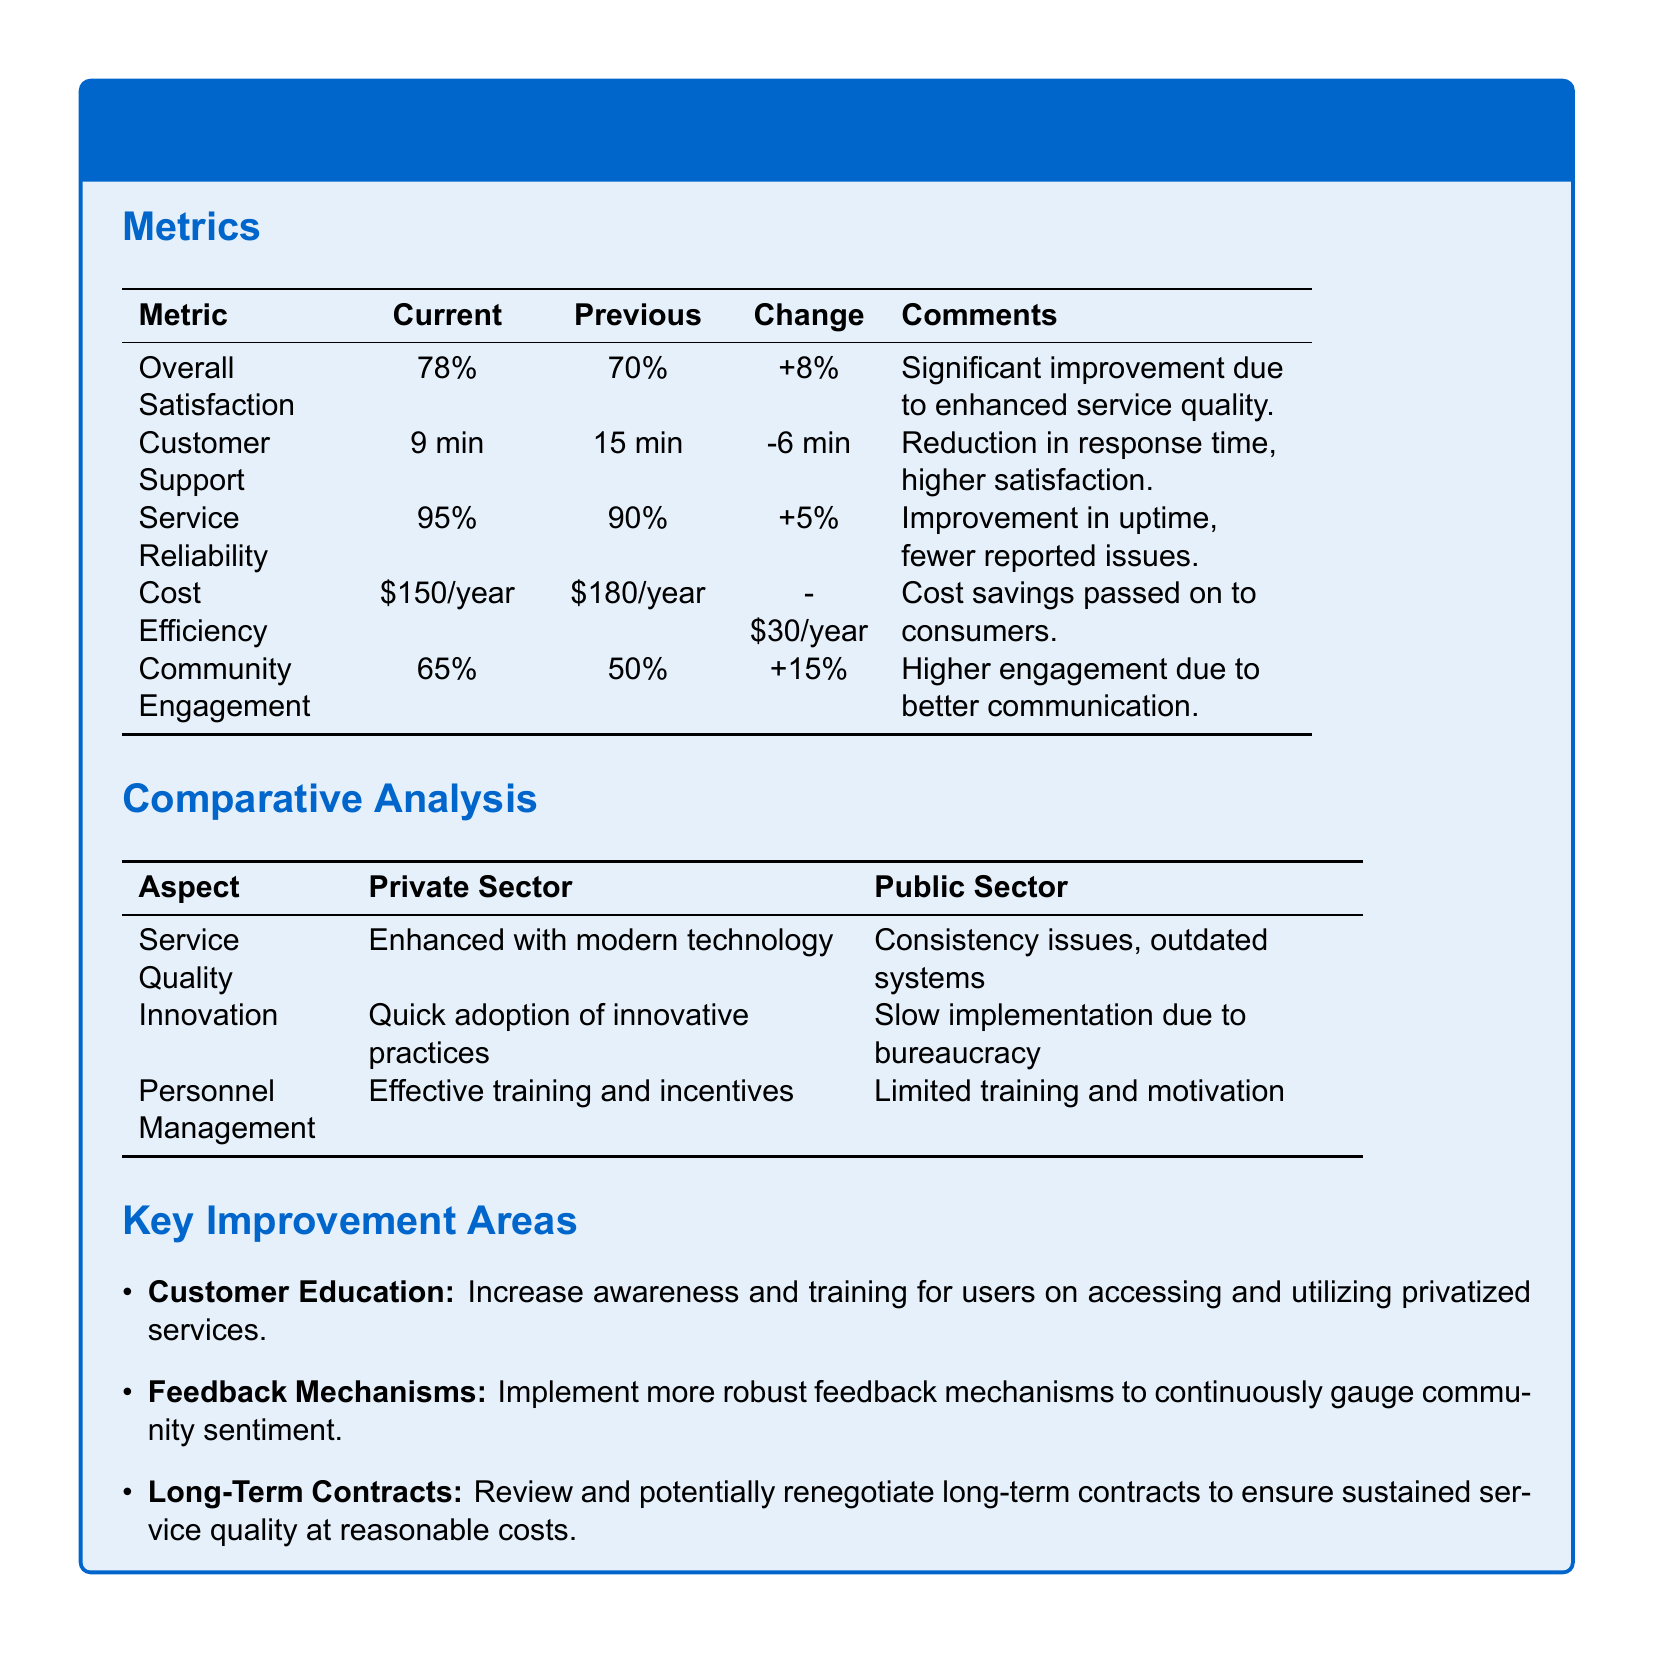What is the overall satisfaction percentage? The overall satisfaction percentage is stated as the current value in the metrics section, which shows a clear figure for current and previous.
Answer: 78% What was the customer support response time previously? The previous customer support response time is clearly listed in the metrics section for ease of comparison.
Answer: 15 min What is the change in cost efficiency? The change in cost efficiency is provided as a direct comparison between the current and previous metrics.
Answer: -$30/year What is the current percentage for community engagement? The current percentage for community engagement is included in the metrics table under current values.
Answer: 65% Which aspect indicates faster adoption of practices in the private sector? The aspect mentioned reflects the advantage of speed attributed to the private sector in adopting modern solutions.
Answer: Innovation What has significantly improved overall satisfaction? The comment next to the overall satisfaction indicates the reason for improvement, providing context within the metrics.
Answer: Enhanced service quality How many key improvement areas are listed? The number of key improvement areas is indicated as they are itemized under the relevant section.
Answer: 3 What is a suggested area for enhancing community involvement? The suggested area is highlighted in the key improvement areas section relating to community engagement.
Answer: Feedback Mechanisms What improves service reliability in the current metrics? The metrics suggest a specific percentage increase showing an improved performance in a particular area.
Answer: 95% 